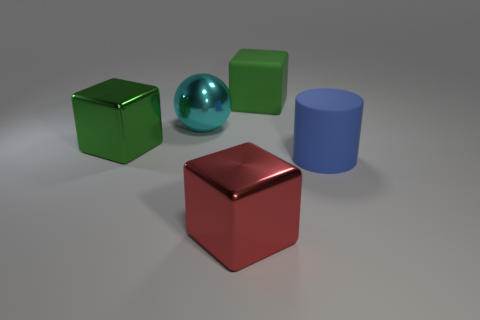There is another object that is made of the same material as the blue thing; what color is it? The object shares the same glossy texture and reflective quality as the blue cylinder, suggesting it's made of a similar material. The color of this object is green, and it's a cube positioned next to the blue cylinder. 